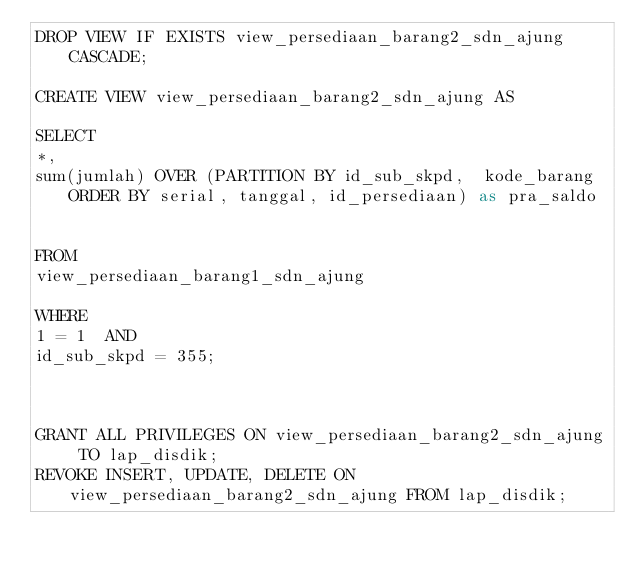<code> <loc_0><loc_0><loc_500><loc_500><_SQL_>DROP VIEW IF EXISTS view_persediaan_barang2_sdn_ajung CASCADE;

CREATE VIEW view_persediaan_barang2_sdn_ajung AS

SELECT
*,
sum(jumlah) OVER (PARTITION BY id_sub_skpd,  kode_barang ORDER BY serial, tanggal, id_persediaan) as pra_saldo


FROM
view_persediaan_barang1_sdn_ajung

WHERE
1 = 1  AND
id_sub_skpd = 355;



GRANT ALL PRIVILEGES ON view_persediaan_barang2_sdn_ajung TO lap_disdik;
REVOKE INSERT, UPDATE, DELETE ON view_persediaan_barang2_sdn_ajung FROM lap_disdik;
</code> 